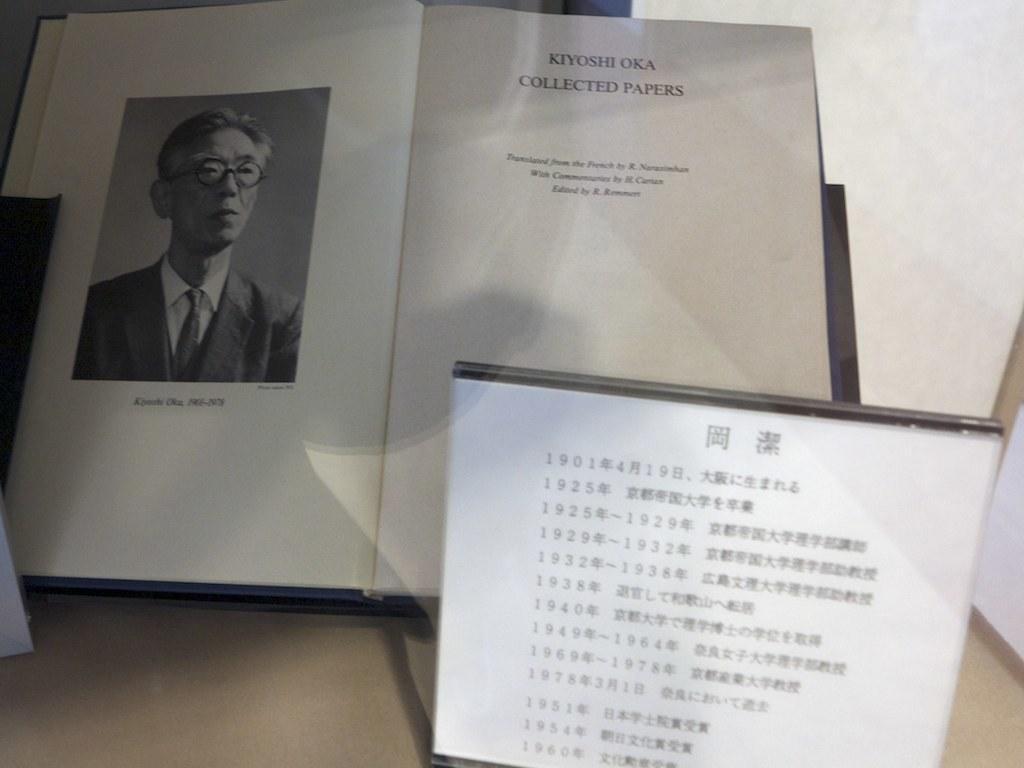Could you give a brief overview of what you see in this image? In this image we can see a book with some text and a photograph on it and there is a board with some text in front of the book. 